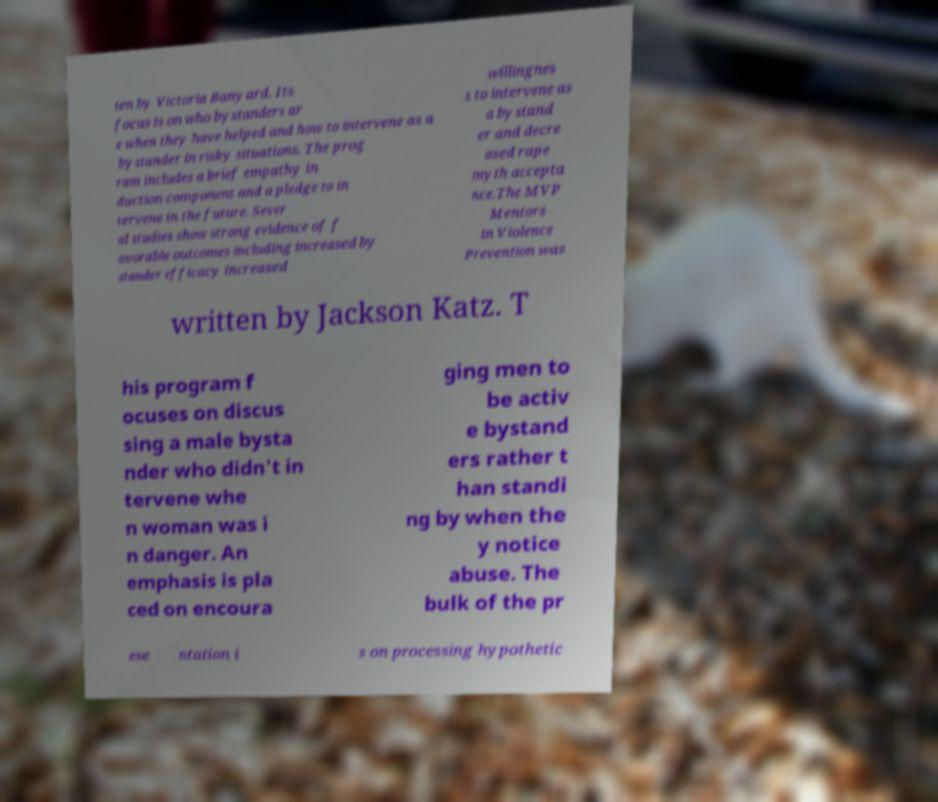Can you accurately transcribe the text from the provided image for me? ten by Victoria Banyard. Its focus is on who bystanders ar e when they have helped and how to intervene as a bystander in risky situations. The prog ram includes a brief empathy in duction component and a pledge to in tervene in the future. Sever al studies show strong evidence of f avorable outcomes including increased by stander efficacy increased willingnes s to intervene as a bystand er and decre ased rape myth accepta nce.The MVP Mentors in Violence Prevention was written by Jackson Katz. T his program f ocuses on discus sing a male bysta nder who didn't in tervene whe n woman was i n danger. An emphasis is pla ced on encoura ging men to be activ e bystand ers rather t han standi ng by when the y notice abuse. The bulk of the pr ese ntation i s on processing hypothetic 